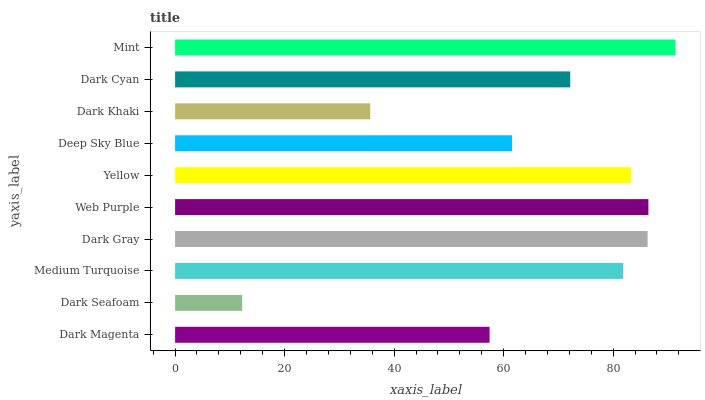Is Dark Seafoam the minimum?
Answer yes or no. Yes. Is Mint the maximum?
Answer yes or no. Yes. Is Medium Turquoise the minimum?
Answer yes or no. No. Is Medium Turquoise the maximum?
Answer yes or no. No. Is Medium Turquoise greater than Dark Seafoam?
Answer yes or no. Yes. Is Dark Seafoam less than Medium Turquoise?
Answer yes or no. Yes. Is Dark Seafoam greater than Medium Turquoise?
Answer yes or no. No. Is Medium Turquoise less than Dark Seafoam?
Answer yes or no. No. Is Medium Turquoise the high median?
Answer yes or no. Yes. Is Dark Cyan the low median?
Answer yes or no. Yes. Is Dark Khaki the high median?
Answer yes or no. No. Is Dark Magenta the low median?
Answer yes or no. No. 